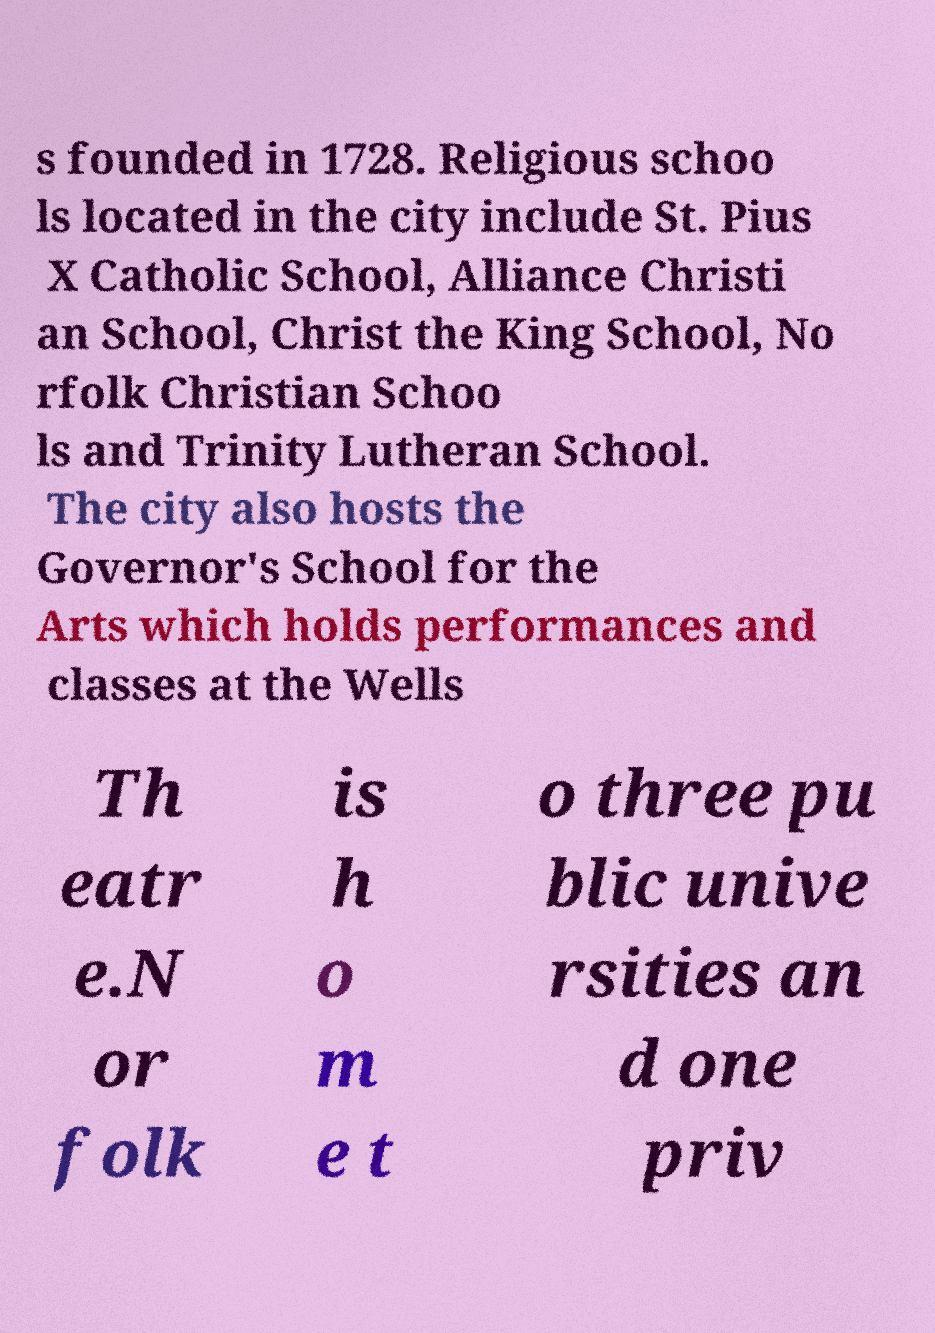There's text embedded in this image that I need extracted. Can you transcribe it verbatim? s founded in 1728. Religious schoo ls located in the city include St. Pius X Catholic School, Alliance Christi an School, Christ the King School, No rfolk Christian Schoo ls and Trinity Lutheran School. The city also hosts the Governor's School for the Arts which holds performances and classes at the Wells Th eatr e.N or folk is h o m e t o three pu blic unive rsities an d one priv 